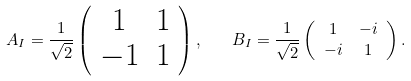Convert formula to latex. <formula><loc_0><loc_0><loc_500><loc_500>A _ { I } = \frac { 1 } { \sqrt { 2 } } \left ( \begin{array} { c c } 1 & 1 \\ - 1 & 1 \end{array} \right ) , \quad & B _ { I } = \frac { 1 } { \sqrt { 2 } } \left ( \begin{array} { c c } 1 & - i \\ - i & 1 \end{array} \right ) .</formula> 